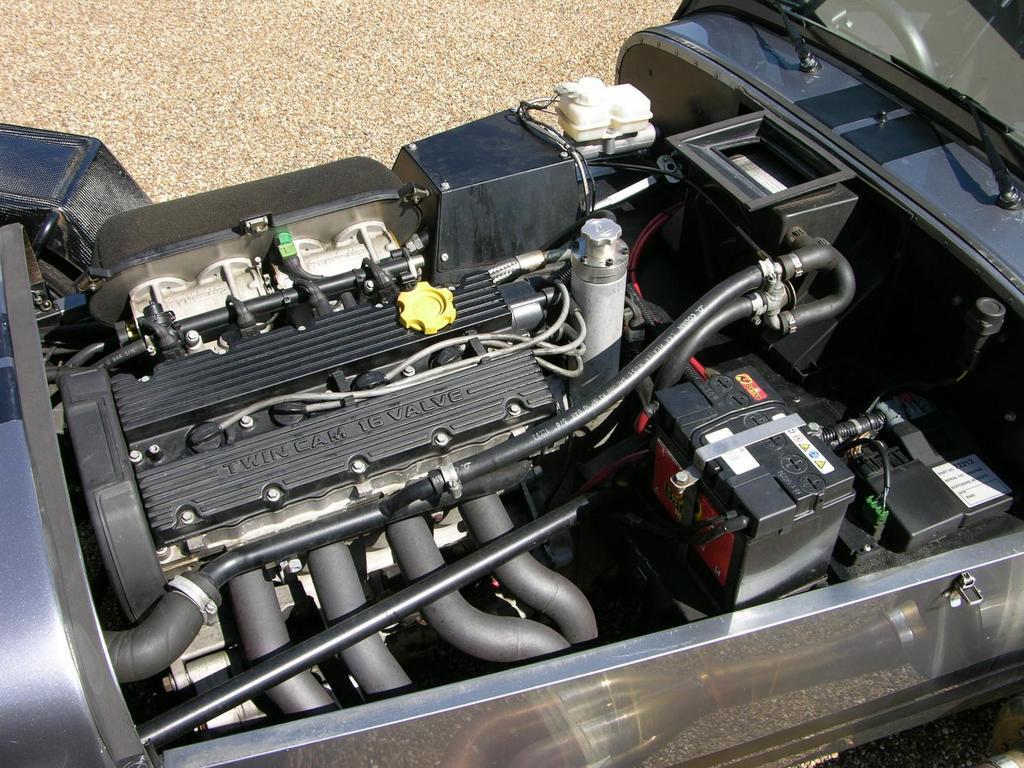How would you summarize this image in a sentence or two? In this image I can see an engine, pipes and some other objects. 